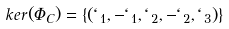<formula> <loc_0><loc_0><loc_500><loc_500>k e r ( \Phi _ { C } ) = \left \{ \left ( \ell _ { 1 } , - \ell _ { 1 } , \ell _ { 2 } , - \ell _ { 2 } , \ell _ { 3 } \right ) \right \}</formula> 